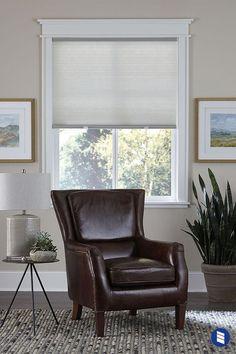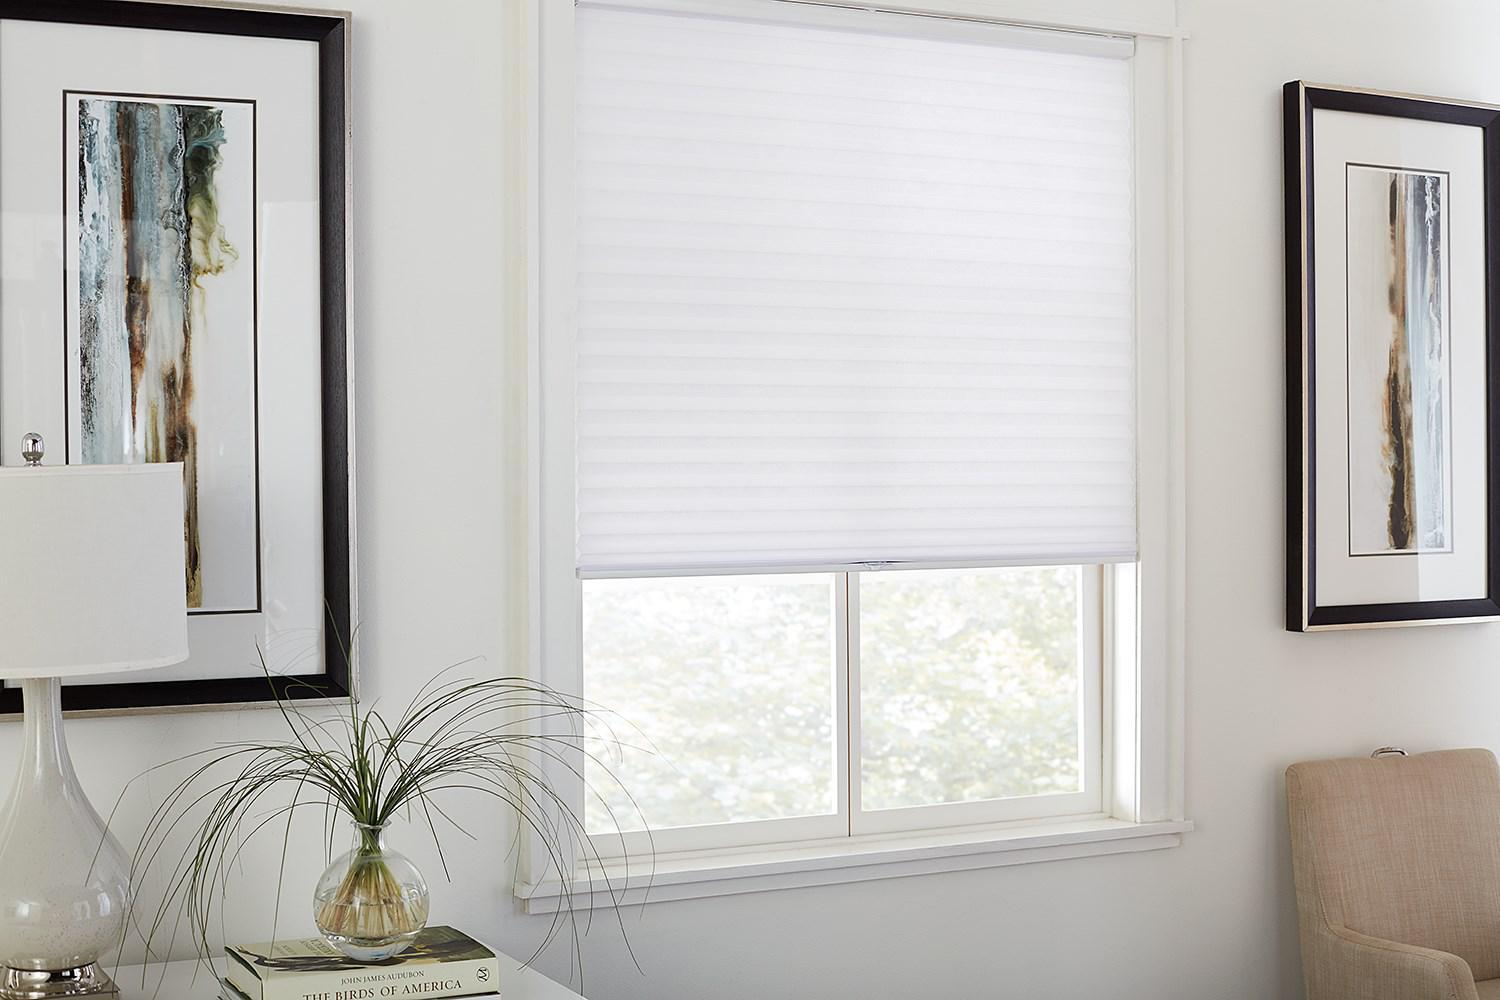The first image is the image on the left, the second image is the image on the right. For the images shown, is this caption "There is exactly one window in the right image." true? Answer yes or no. Yes. The first image is the image on the left, the second image is the image on the right. For the images displayed, is the sentence "There is a total of two blinds." factually correct? Answer yes or no. Yes. 